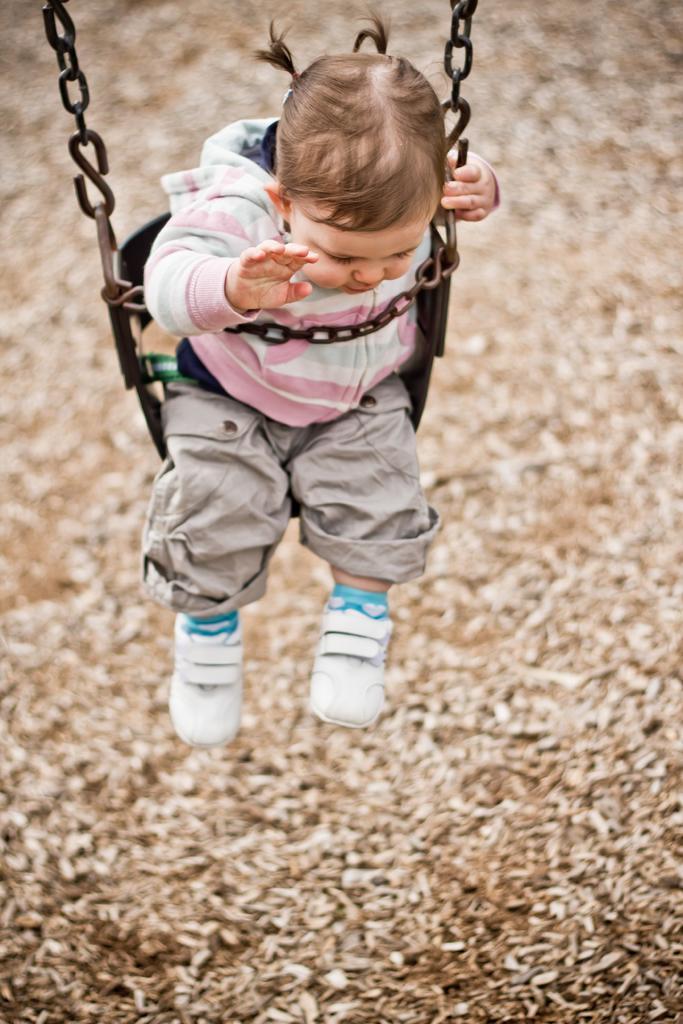In one or two sentences, can you explain what this image depicts? In this picture there is a kid in a swing. At the bottom it is dry leaves. The background is blurred. 